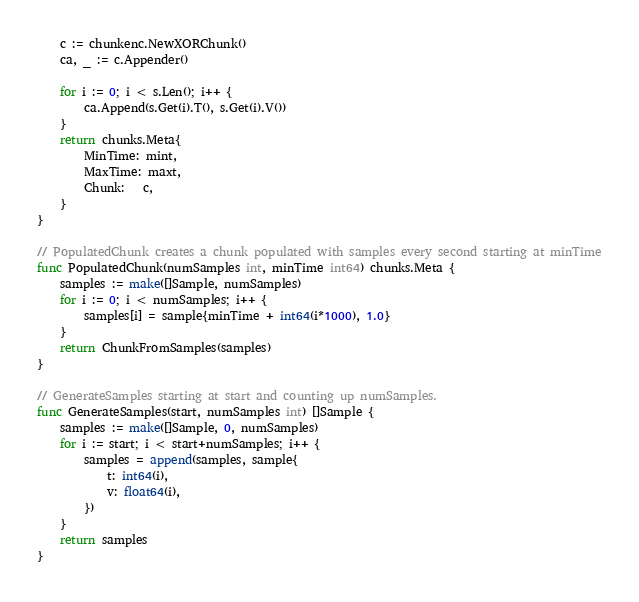<code> <loc_0><loc_0><loc_500><loc_500><_Go_>
	c := chunkenc.NewXORChunk()
	ca, _ := c.Appender()

	for i := 0; i < s.Len(); i++ {
		ca.Append(s.Get(i).T(), s.Get(i).V())
	}
	return chunks.Meta{
		MinTime: mint,
		MaxTime: maxt,
		Chunk:   c,
	}
}

// PopulatedChunk creates a chunk populated with samples every second starting at minTime
func PopulatedChunk(numSamples int, minTime int64) chunks.Meta {
	samples := make([]Sample, numSamples)
	for i := 0; i < numSamples; i++ {
		samples[i] = sample{minTime + int64(i*1000), 1.0}
	}
	return ChunkFromSamples(samples)
}

// GenerateSamples starting at start and counting up numSamples.
func GenerateSamples(start, numSamples int) []Sample {
	samples := make([]Sample, 0, numSamples)
	for i := start; i < start+numSamples; i++ {
		samples = append(samples, sample{
			t: int64(i),
			v: float64(i),
		})
	}
	return samples
}
</code> 